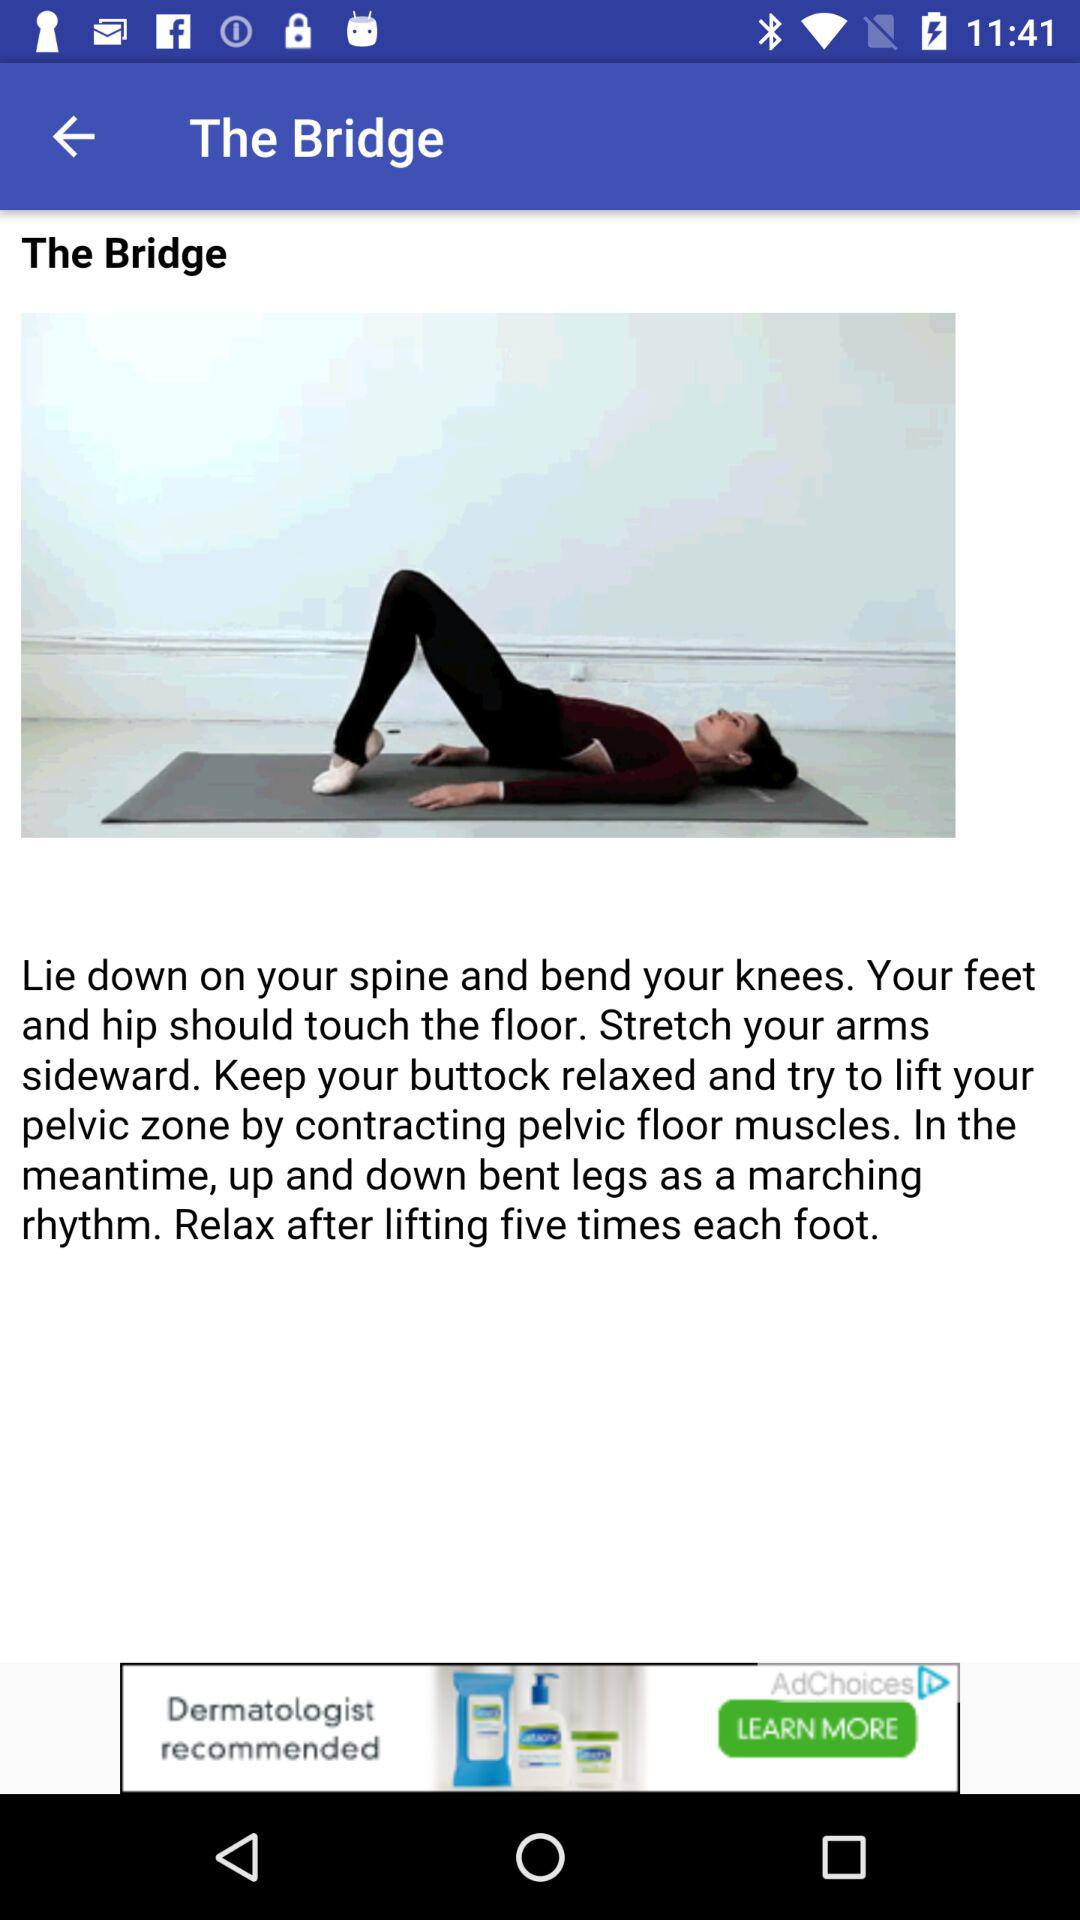What is the alignment of the arms in the bridge position? The alignment of the arms is sideward. 